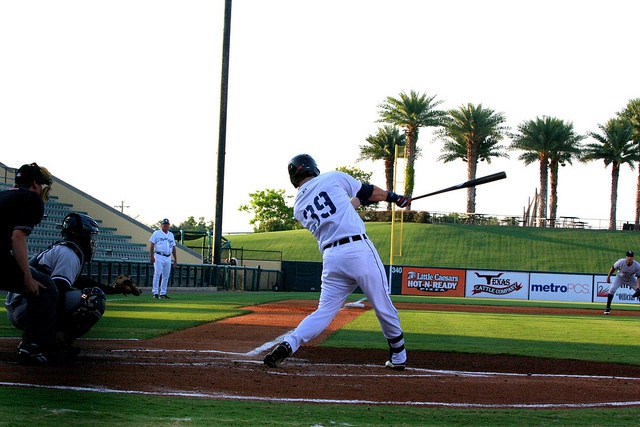Describe the objects in this image and their specific colors. I can see people in white, lightblue, black, and gray tones, people in white, black, maroon, gray, and blue tones, people in white, black, gray, navy, and blue tones, people in white, lightblue, gray, and black tones, and people in white, black, purple, gray, and navy tones in this image. 